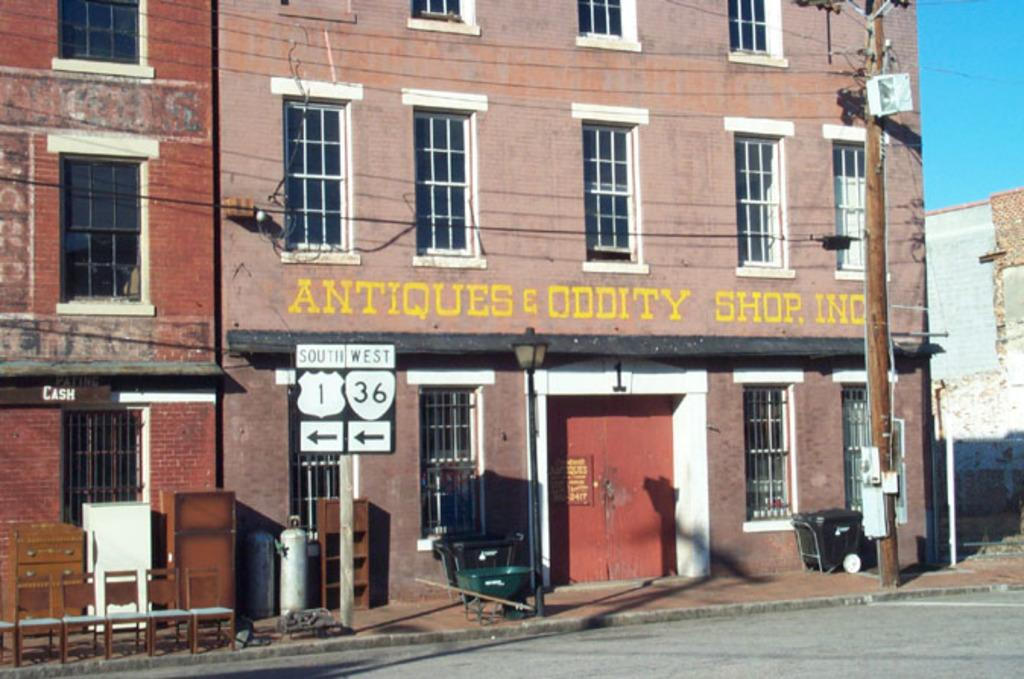What type of structure is visible in the image? There is a building in the image. What can be seen on the ground in front of the building? There are objects placed on the path of a road in front of the building. What type of information might be conveyed by the sign board in the image? The sign board in the image might convey information about the building or the surrounding area. What is the purpose of the utility pole in the image? The utility pole in the image is likely used for supporting electrical or communication wires. What is visible in the background of the image? The sky is visible in the background of the image. How many carpenters are working on the island in the image? There is no island or carpenters present in the image. 